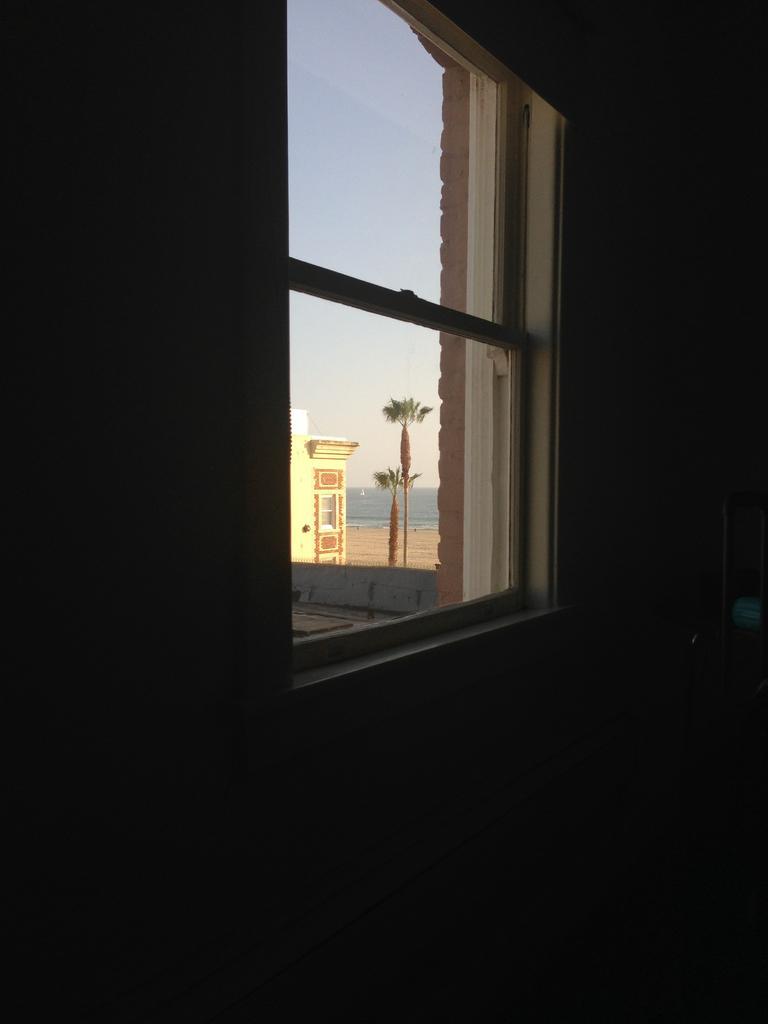Describe this image in one or two sentences. In this image we can see a wall, window through which we can see a building, trees, water, sky and sand. 